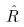Convert formula to latex. <formula><loc_0><loc_0><loc_500><loc_500>\hat { R }</formula> 